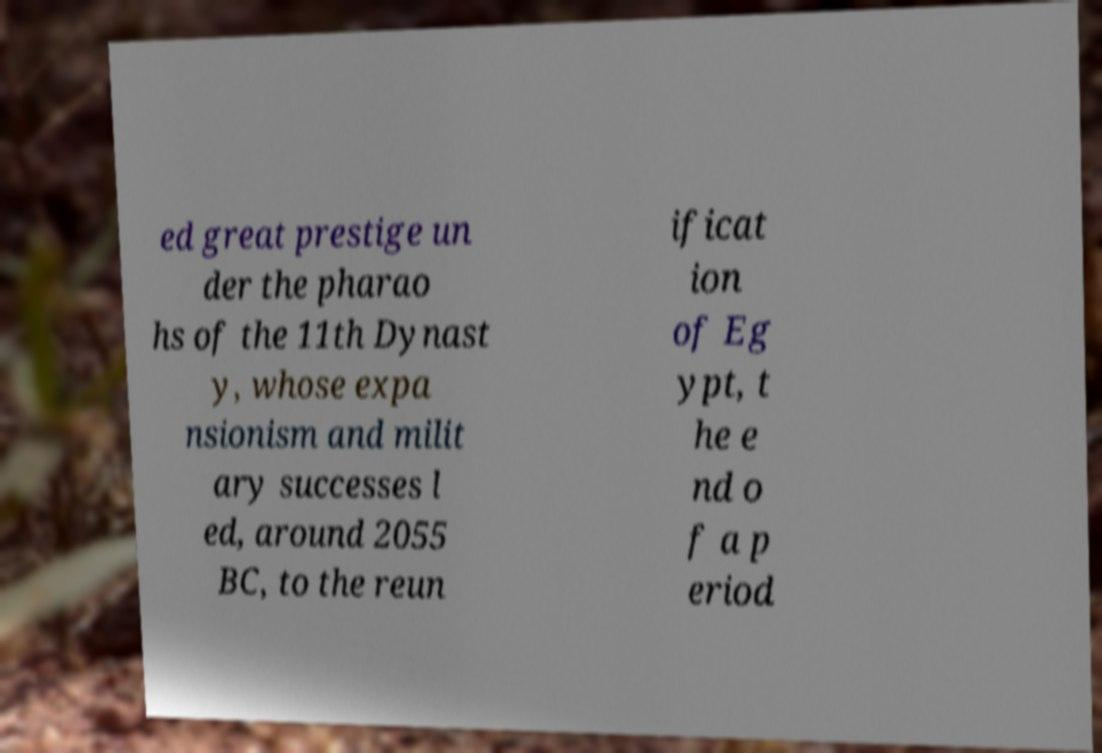Please read and relay the text visible in this image. What does it say? ed great prestige un der the pharao hs of the 11th Dynast y, whose expa nsionism and milit ary successes l ed, around 2055 BC, to the reun ificat ion of Eg ypt, t he e nd o f a p eriod 